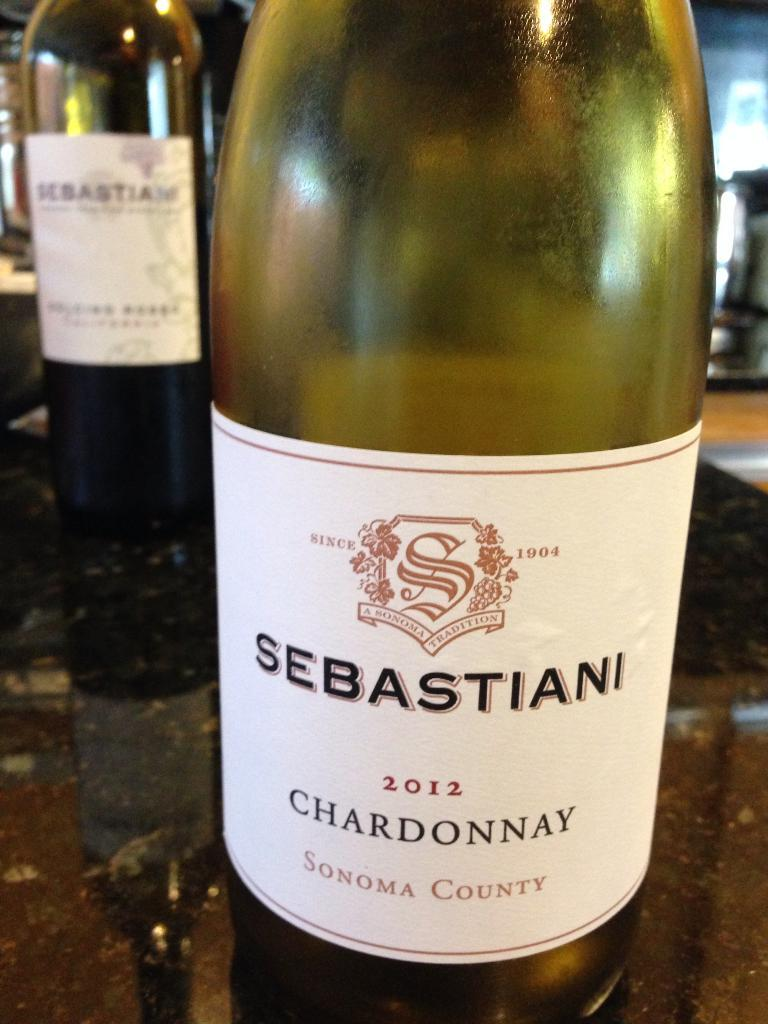<image>
Give a short and clear explanation of the subsequent image. A bottle of Sebastiani chardonnay on a counter. 